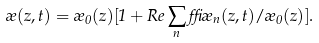<formula> <loc_0><loc_0><loc_500><loc_500>\rho ( z , t ) = \rho _ { 0 } ( z ) [ 1 + R e \sum _ { n } \delta \rho _ { n } ( z , t ) / \rho _ { 0 } ( z ) ] .</formula> 